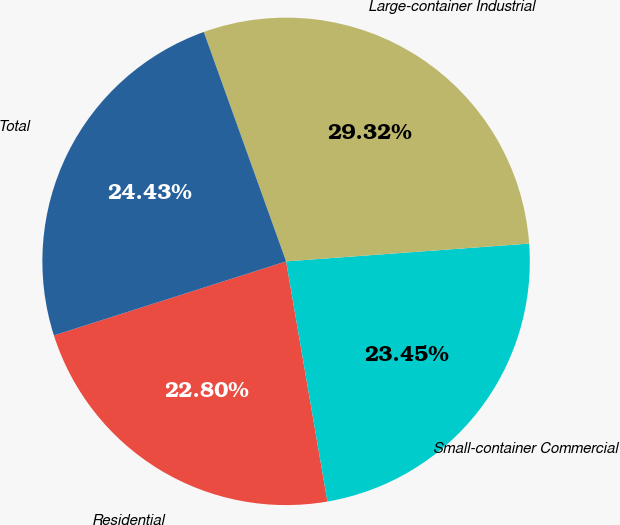Convert chart. <chart><loc_0><loc_0><loc_500><loc_500><pie_chart><fcel>Residential<fcel>Small-container Commercial<fcel>Large-container Industrial<fcel>Total<nl><fcel>22.8%<fcel>23.45%<fcel>29.32%<fcel>24.43%<nl></chart> 